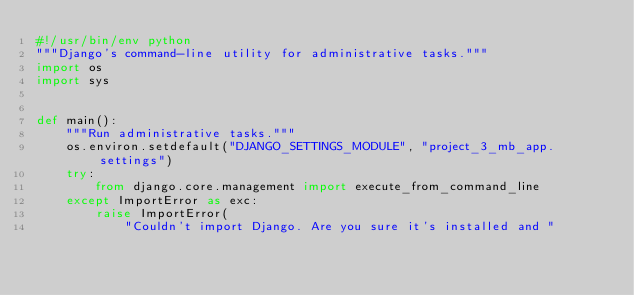Convert code to text. <code><loc_0><loc_0><loc_500><loc_500><_Python_>#!/usr/bin/env python
"""Django's command-line utility for administrative tasks."""
import os
import sys


def main():
    """Run administrative tasks."""
    os.environ.setdefault("DJANGO_SETTINGS_MODULE", "project_3_mb_app.settings")
    try:
        from django.core.management import execute_from_command_line
    except ImportError as exc:
        raise ImportError(
            "Couldn't import Django. Are you sure it's installed and "</code> 